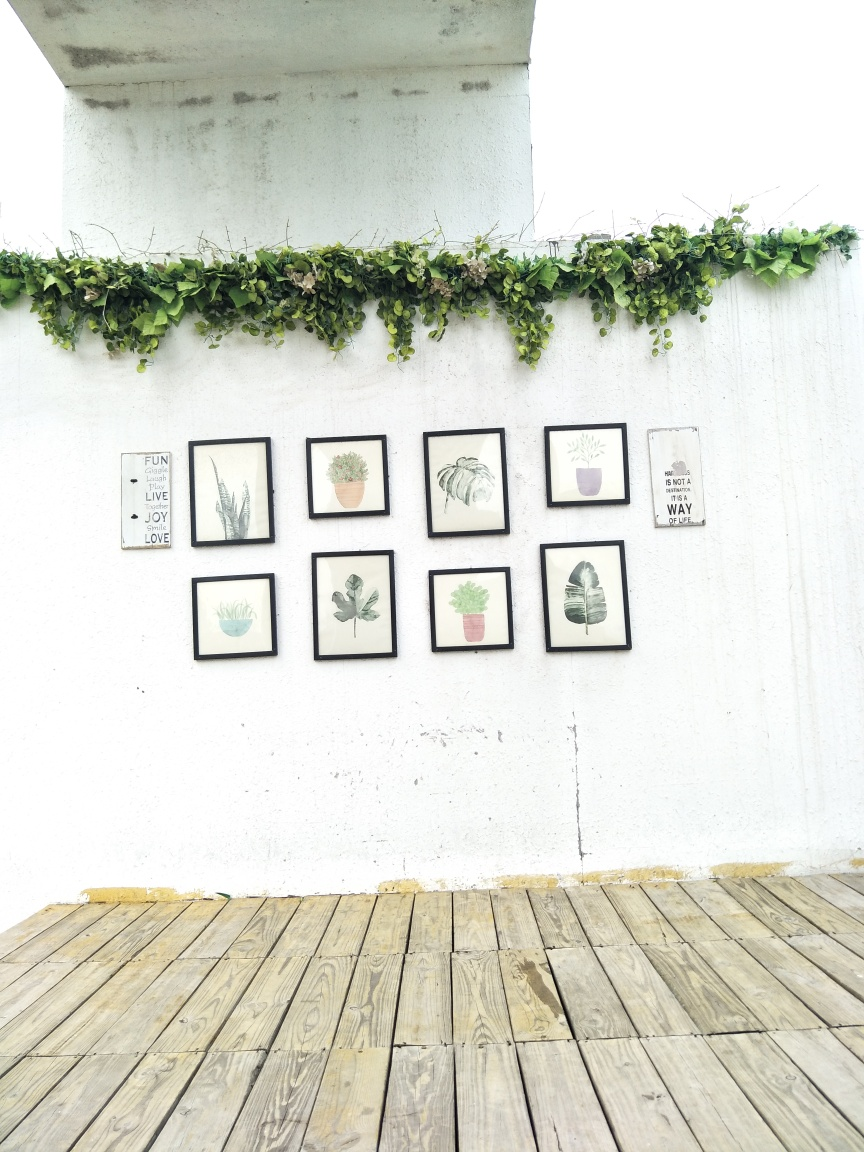How does the arrangement of the framed illustrations contribute to the decor of the space? The arrangement of the framed illustrations creates a focal point on the white wall, drawing attention to the carefully selected botanical themes within the frames. The symmetrical placement of the frames adds a sense of order and balance to the space, while the varying sizes and orientations of the frames create visual interest. Together, they contribute to a serene and organized atmosphere, reflecting a nature-inspired decor that's both simple and elegant. 